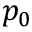Convert formula to latex. <formula><loc_0><loc_0><loc_500><loc_500>p _ { 0 }</formula> 